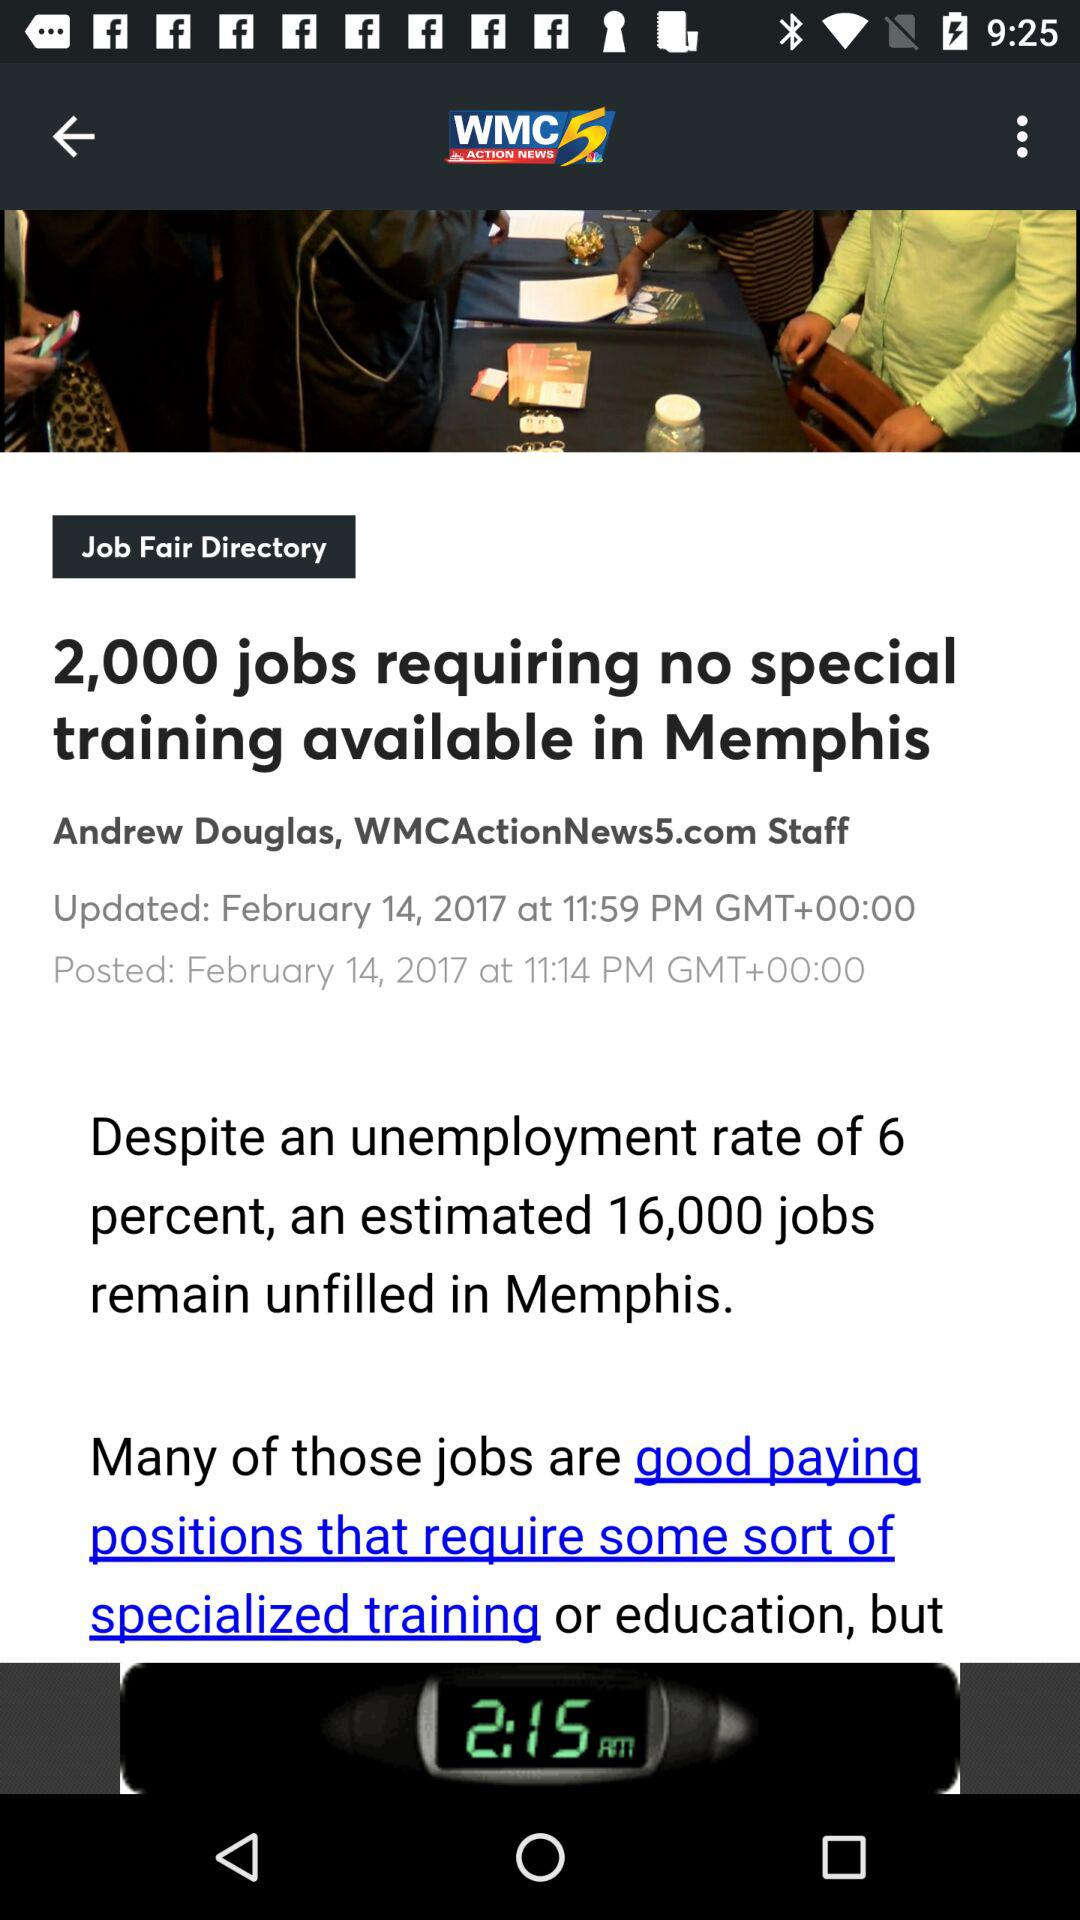What is the posted time of the article? The posted time of the article is 11:14 PM. 